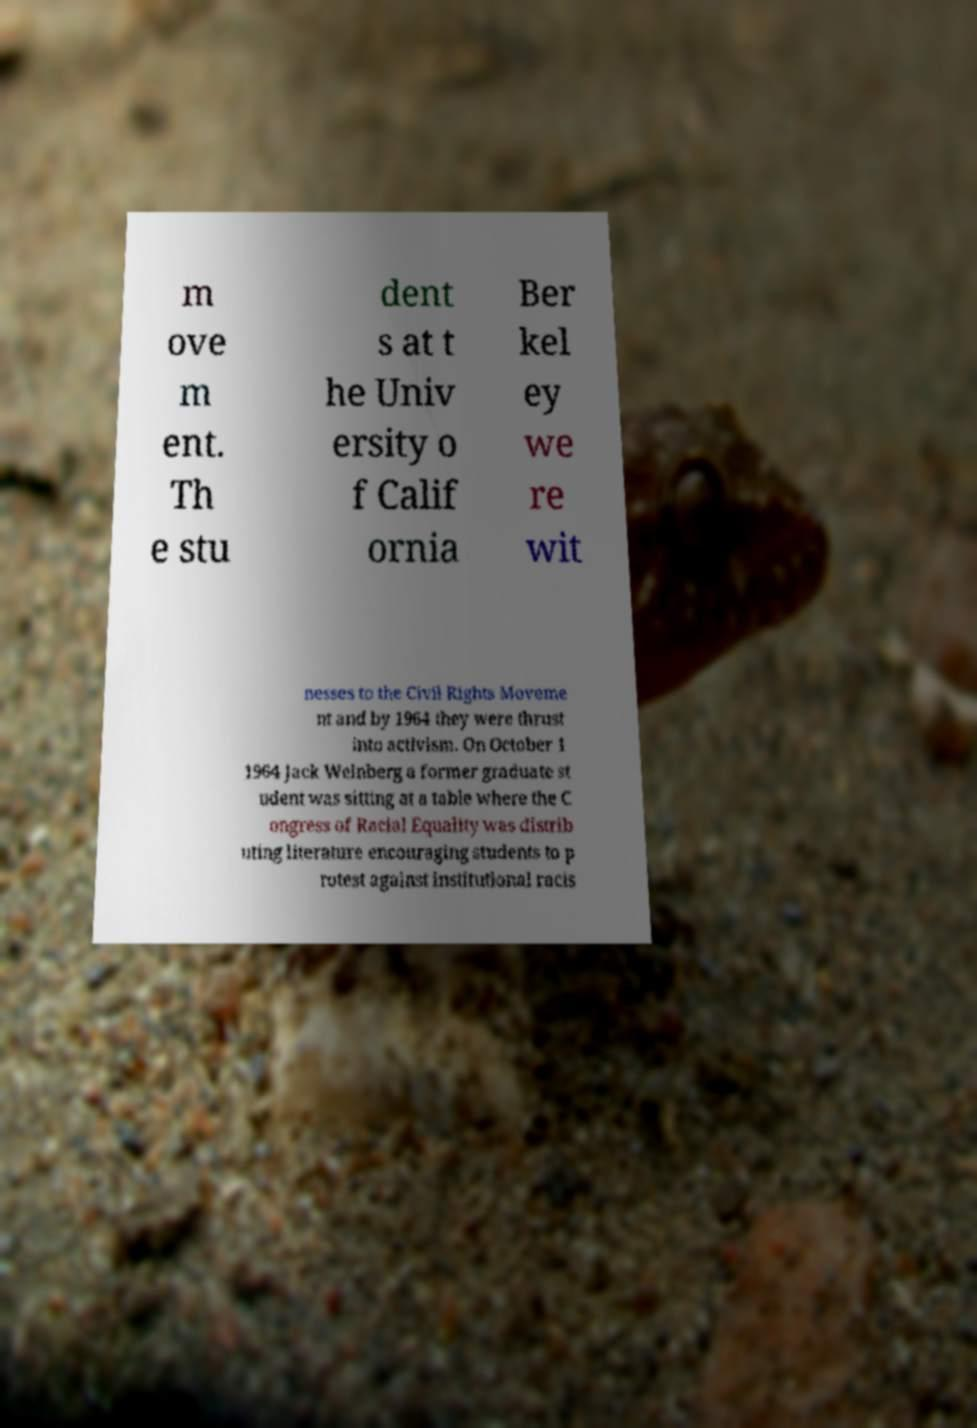Could you extract and type out the text from this image? m ove m ent. Th e stu dent s at t he Univ ersity o f Calif ornia Ber kel ey we re wit nesses to the Civil Rights Moveme nt and by 1964 they were thrust into activism. On October 1 1964 Jack Weinberg a former graduate st udent was sitting at a table where the C ongress of Racial Equality was distrib uting literature encouraging students to p rotest against institutional racis 